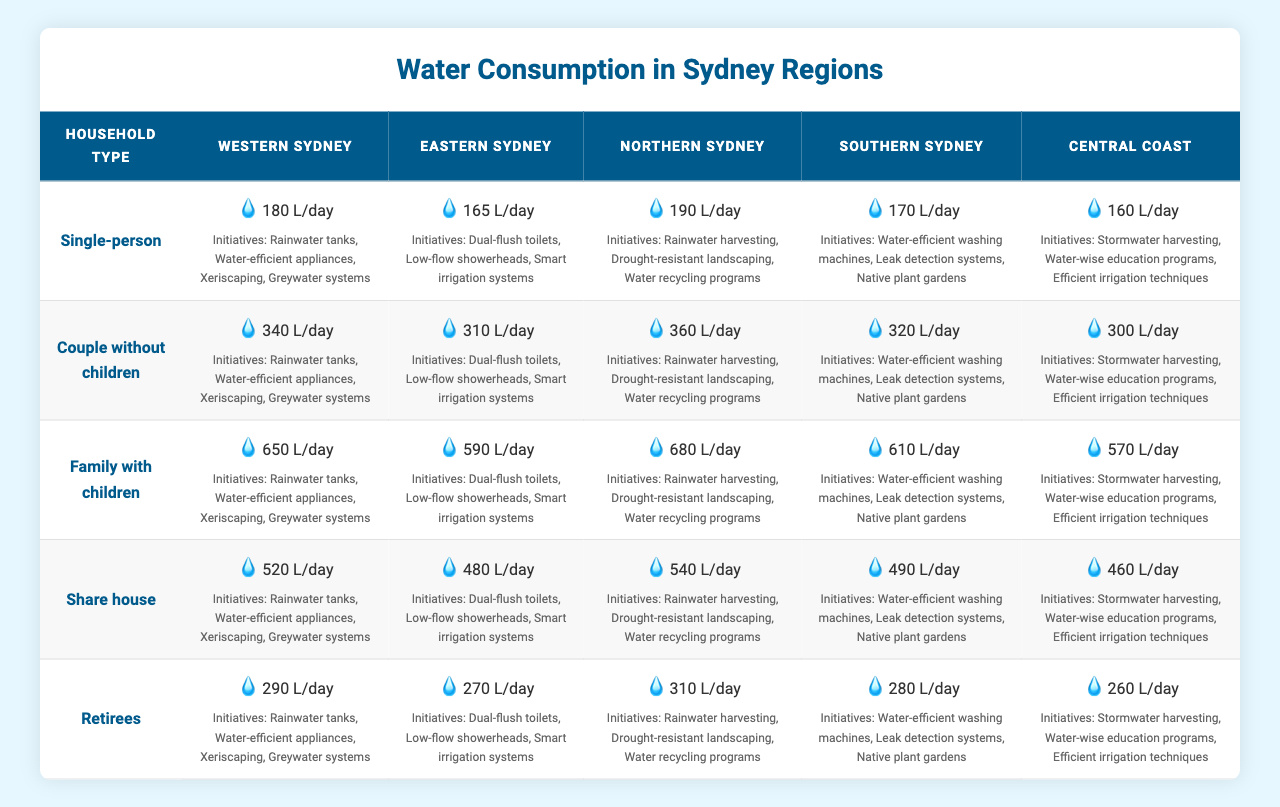What is the water consumption for a "Family with children" in Western Sydney? The table shows that in Western Sydney, the water consumption for a "Family with children" is 650 litres per day.
Answer: 650 litres per day Which region has the highest water consumption for "Single-person" households? By comparing the values for "Single-person" households across all regions, Northern Sydney has the highest consumption at 190 litres per day.
Answer: Northern Sydney What is the difference in water consumption between "Couple without children" in Western Sydney and Central Coast? The water consumption for "Couple without children" in Western Sydney is 340 litres per day, while in Central Coast it is 300 litres per day. The difference is 340 - 300 = 40 litres per day.
Answer: 40 litres Which household type requires the least amount of water in Eastern Sydney? In Eastern Sydney, "Retirees" have the lowest consumption rate of 270 litres per day compared to other household types: 165 (Single-person), 310 (Couple without children), and 590 (Family with children).
Answer: Retirees Is water consumption for "Share house" in Western Sydney higher than in Southern Sydney? The consumption for "Share house" in Western Sydney is 520 litres per day, while in Southern Sydney it is 490 litres per day. Therefore, it is true that Western Sydney's consumption is higher.
Answer: Yes What is the average water consumption for "Retirees" across all regions? The consumption rates for "Retirees" are 290 (Western Sydney), 270 (Eastern Sydney), 310 (Northern Sydney), 280 (Southern Sydney), and 260 (Central Coast). The total consumption is 290 + 270 + 310 + 280 + 260 = 1410 litres. The average is then 1410 / 5 = 282 litres per day.
Answer: 282 litres per day Which region has the same consumption rate for "Couple without children" and "Retirees"? In the table, "Couple without children" consumes 340 litres in Western Sydney and 310 litres in Northern Sydney, while "Retirees" consume 290 litres in Western Sydney and 310 litres in Northern Sydney. Thus, Southern Sydney is the only region where the two categories have equal consumption rates; both are 320 litres per day.
Answer: Southern Sydney What are the water-saving initiatives available in the region with the lowest consumption for "Single-person" households? From the table, Central Coast has the lowest consumption for "Single-person" households at 160 litres per day. The water-saving initiatives listed for Central Coast include stormwater harvesting, water-wise education programs, and efficient irrigation techniques.
Answer: Stormwater harvesting, water-wise education programs, efficient irrigation techniques How many litres more does a "Family with children" in Northern Sydney consume compared to a "Couple without children" in Eastern Sydney? In Northern Sydney, "Family with children" consumes 680 litres per day, while "Couple without children" in Eastern Sydney consumes 310 litres per day. The difference is 680 - 310 = 370 litres.
Answer: 370 litres Is the water consumption for "Share house" in Central Coast above the average consumption of "Single-person" households across all regions? The average for "Single-person" households is (180 + 165 + 190 + 170 + 160) / 5 = 173 litres per day. The consumption for "Share house" in Central Coast is 460 litres per day, which is above the average of 173 litres. Thus, the statement is true.
Answer: Yes 